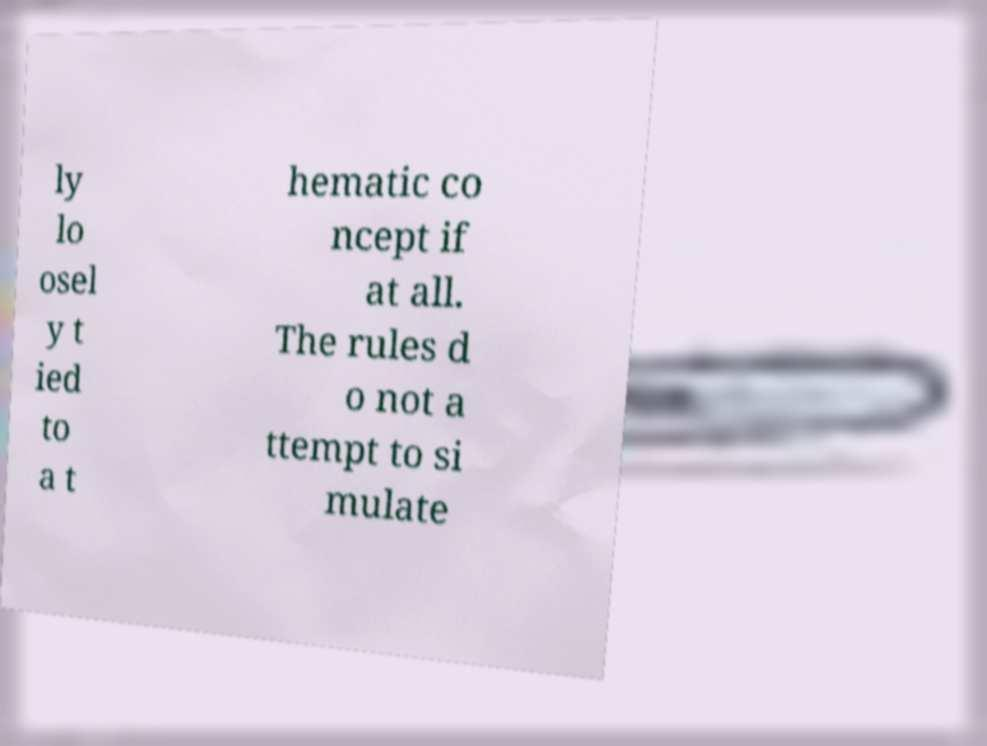I need the written content from this picture converted into text. Can you do that? ly lo osel y t ied to a t hematic co ncept if at all. The rules d o not a ttempt to si mulate 